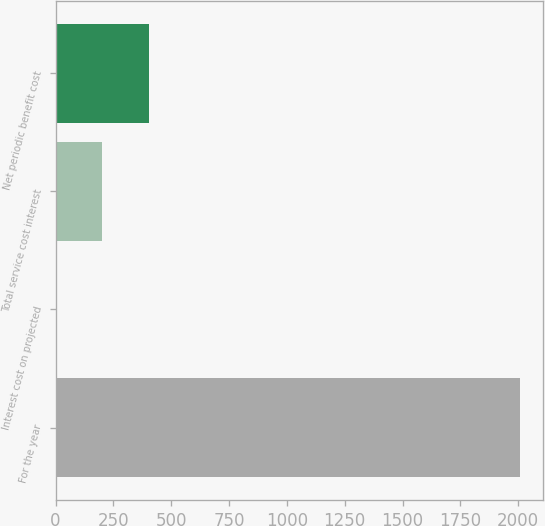<chart> <loc_0><loc_0><loc_500><loc_500><bar_chart><fcel>For the year<fcel>Interest cost on projected<fcel>Total service cost interest<fcel>Net periodic benefit cost<nl><fcel>2007<fcel>1<fcel>201.6<fcel>402.2<nl></chart> 